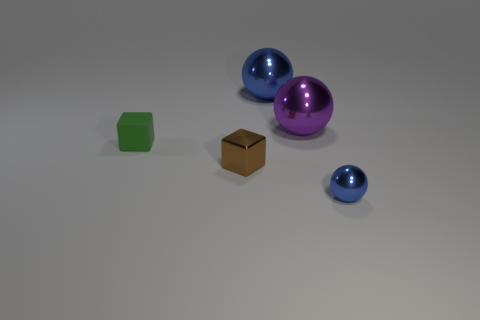Add 4 big brown rubber cylinders. How many objects exist? 9 Subtract all cubes. How many objects are left? 3 Subtract all red shiny cylinders. Subtract all big blue objects. How many objects are left? 4 Add 3 tiny shiny balls. How many tiny shiny balls are left? 4 Add 2 large blue metallic things. How many large blue metallic things exist? 3 Subtract 0 red cubes. How many objects are left? 5 